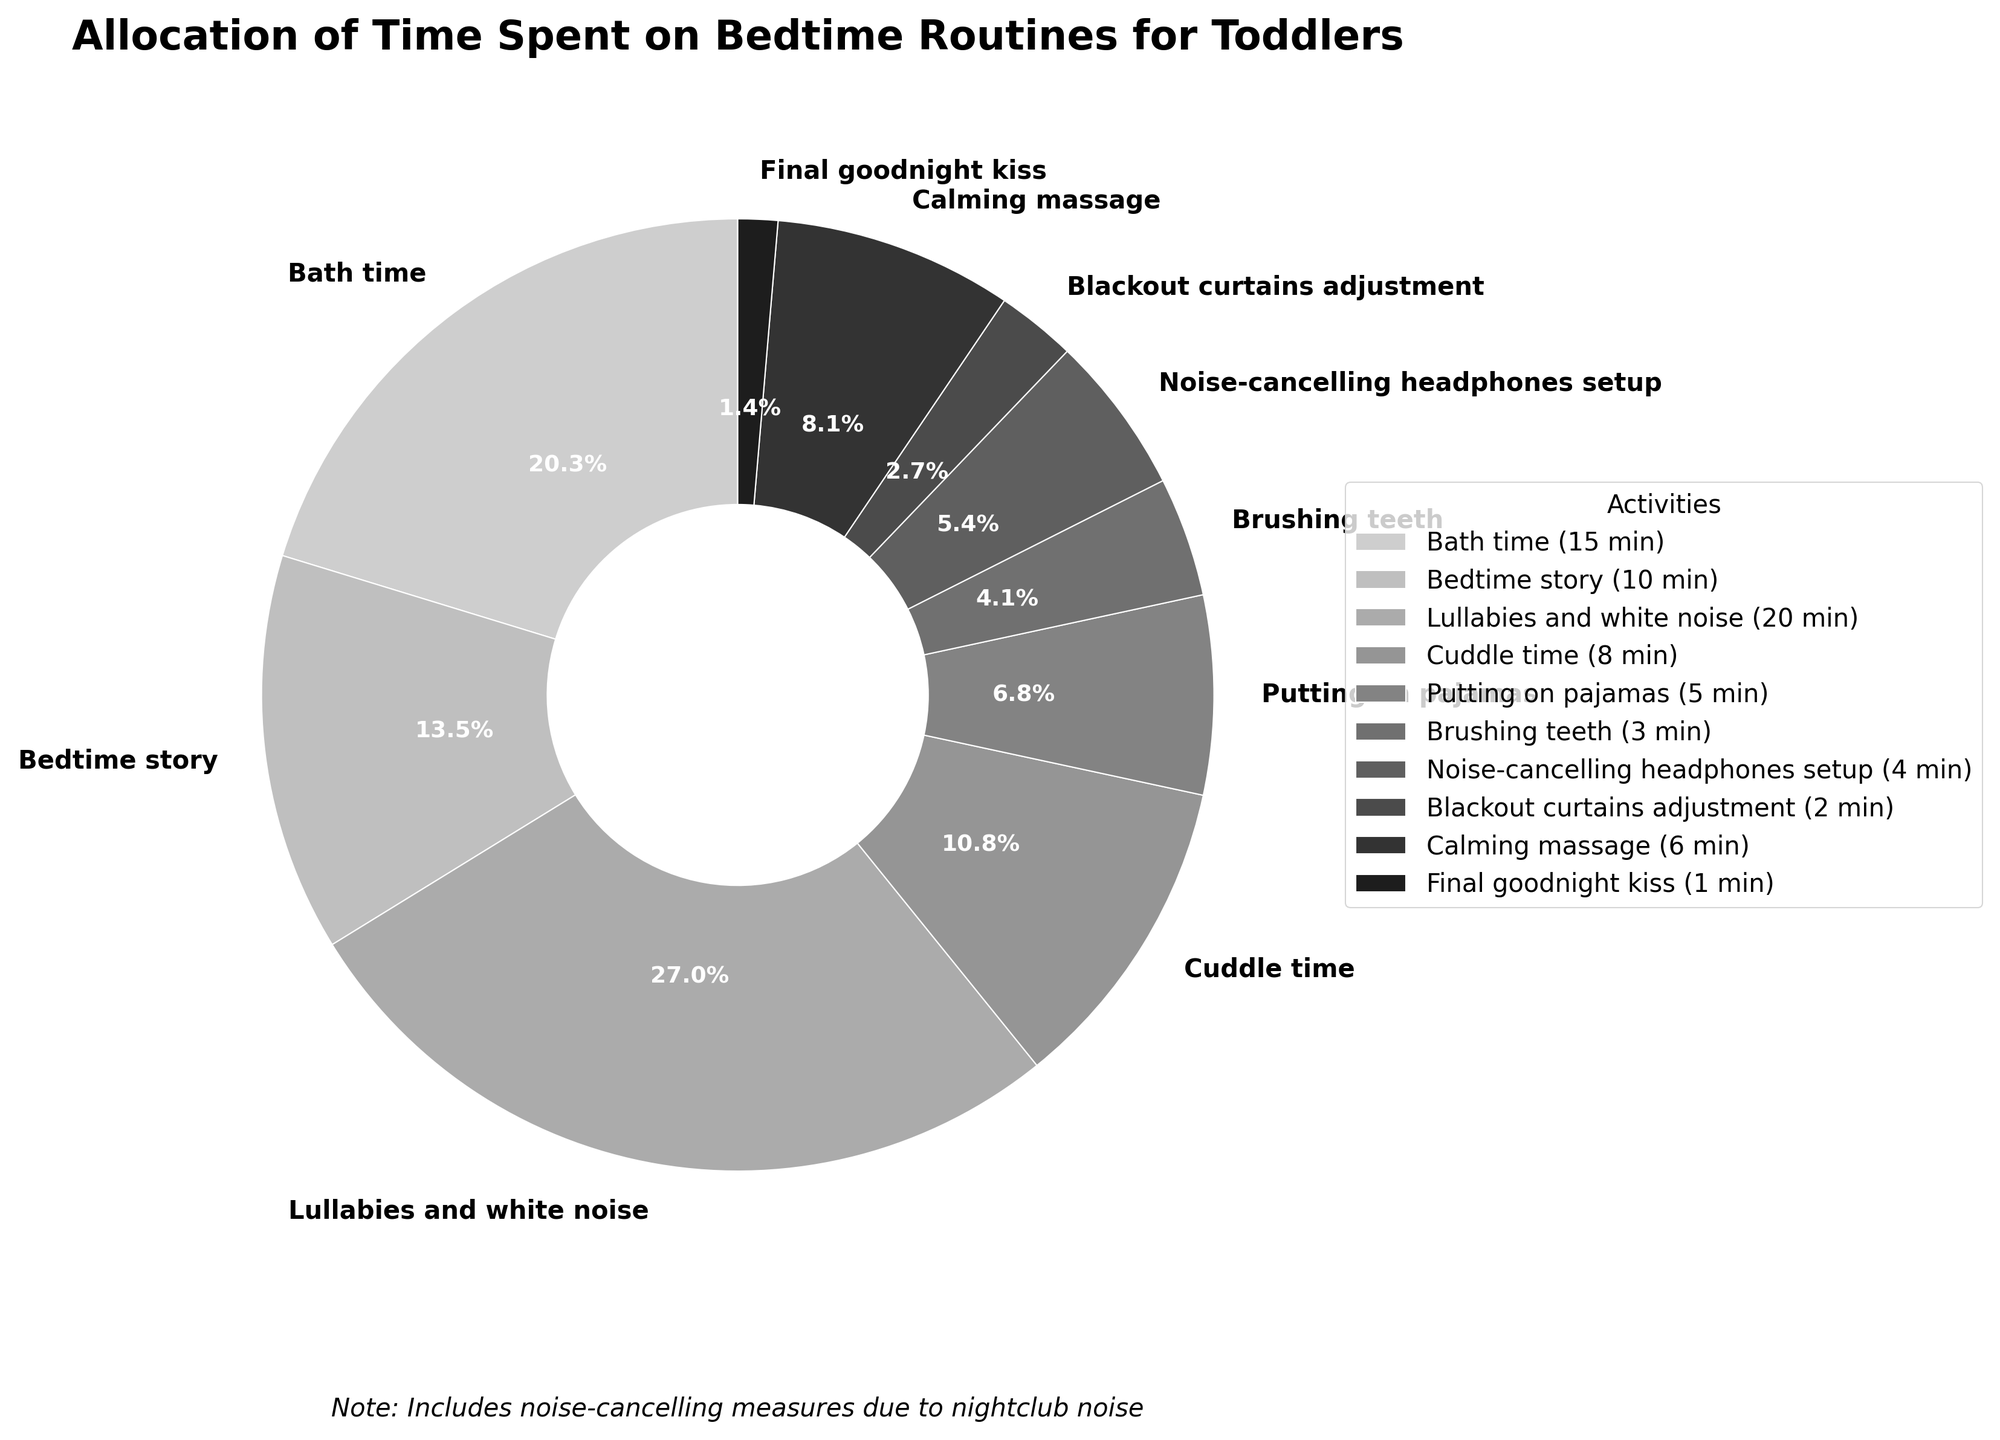How much time is spent on brushing teeth compared to putting on pajamas? Brushing teeth takes 3 minutes, and putting on pajamas takes 5 minutes. 3 is less than 5, so brushing teeth takes less time than putting on pajamas.
Answer: Brushing teeth takes less time Which activity takes up the most time, and how many minutes is it? "Lullabies and white noise" takes the most time with 20 minutes. This can be seen as the largest portion of the pie chart.
Answer: Lullabies and white noise (20 minutes) How much time is spent on noise-cancelling measures in total? The noise-cancelling measures are identified as "Noise-cancelling headphones setup" and "Blackout curtains adjustment." The total time spent on these is 4 + 2 = 6 minutes.
Answer: 6 minutes Which takes less time: Blackout curtains adjustment or Final goodnight kiss? The time spent on blackout curtains adjustment is 2 minutes and the time spent on the final goodnight kiss is 1 minute. Since 1 < 2, the final goodnight kiss takes less time.
Answer: Final goodnight kiss What percentage of the time is spent on calming massage and cuddle time combined? Calming massage takes 6 minutes and cuddle time takes 8 minutes. Combined, they take 6 + 8 = 14 minutes. The total time of all activities sums to 74 minutes. The combined percentage is (14/74) * 100 ≈ 18.9%.
Answer: 18.9% How does the time spent on the bedtime story compare to the time spent putting on pajamas and brushing teeth combined? Bedtime story takes 10 minutes, and the combined time for putting on pajamas (5 minutes) and brushing teeth (3 minutes) is 5 + 3 = 8 minutes. Since 10 > 8, the bedtime story takes more time.
Answer: Bedtime story takes more time Which activities have equal time allocations? By observing the pie chart, "Noise-cancelling headphones setup" and "Blackout curtains adjustment" can be seen to have similar visual representations. Confirming the actual data: Noise-cancelling headphones setup = 4 minutes, Blackout curtains adjustment = 2 minutes.
Answer: None What is the combined time spent on bath time, bedtime story, and lullabies and white noise? Bath time is 15 minutes, bedtime story is 10 minutes, and lullabies and white noise is 20 minutes. Combined, they are 15 + 10 + 20 = 45 minutes.
Answer: 45 minutes Which activity takes exactly 1 minute, and what is the overall impact of this in percentages? The activity that takes exactly 1 minute is the "Final goodnight kiss". The total time for all activities is 74 minutes. Therefore, its percentage is (1/74) * 100 ≈ 1.4%.
Answer: Final goodnight kiss, 1.4% What is the total percentage of relaxing activities like cuddle time, calming massage, and lullabies and white noise? Cuddle time, calming massage, and lullabies and white noise are 8 minutes, 6 minutes, and 20 minutes respectively. Combined, they are 8 + 6 + 20 = 34 minutes. Percentage is (34/74) * 100 ≈ 45.9%.
Answer: 45.9% 